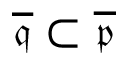<formula> <loc_0><loc_0><loc_500><loc_500>{ \overline { { \mathfrak { q } } } } \subset { \overline { { \mathfrak { p } } } }</formula> 